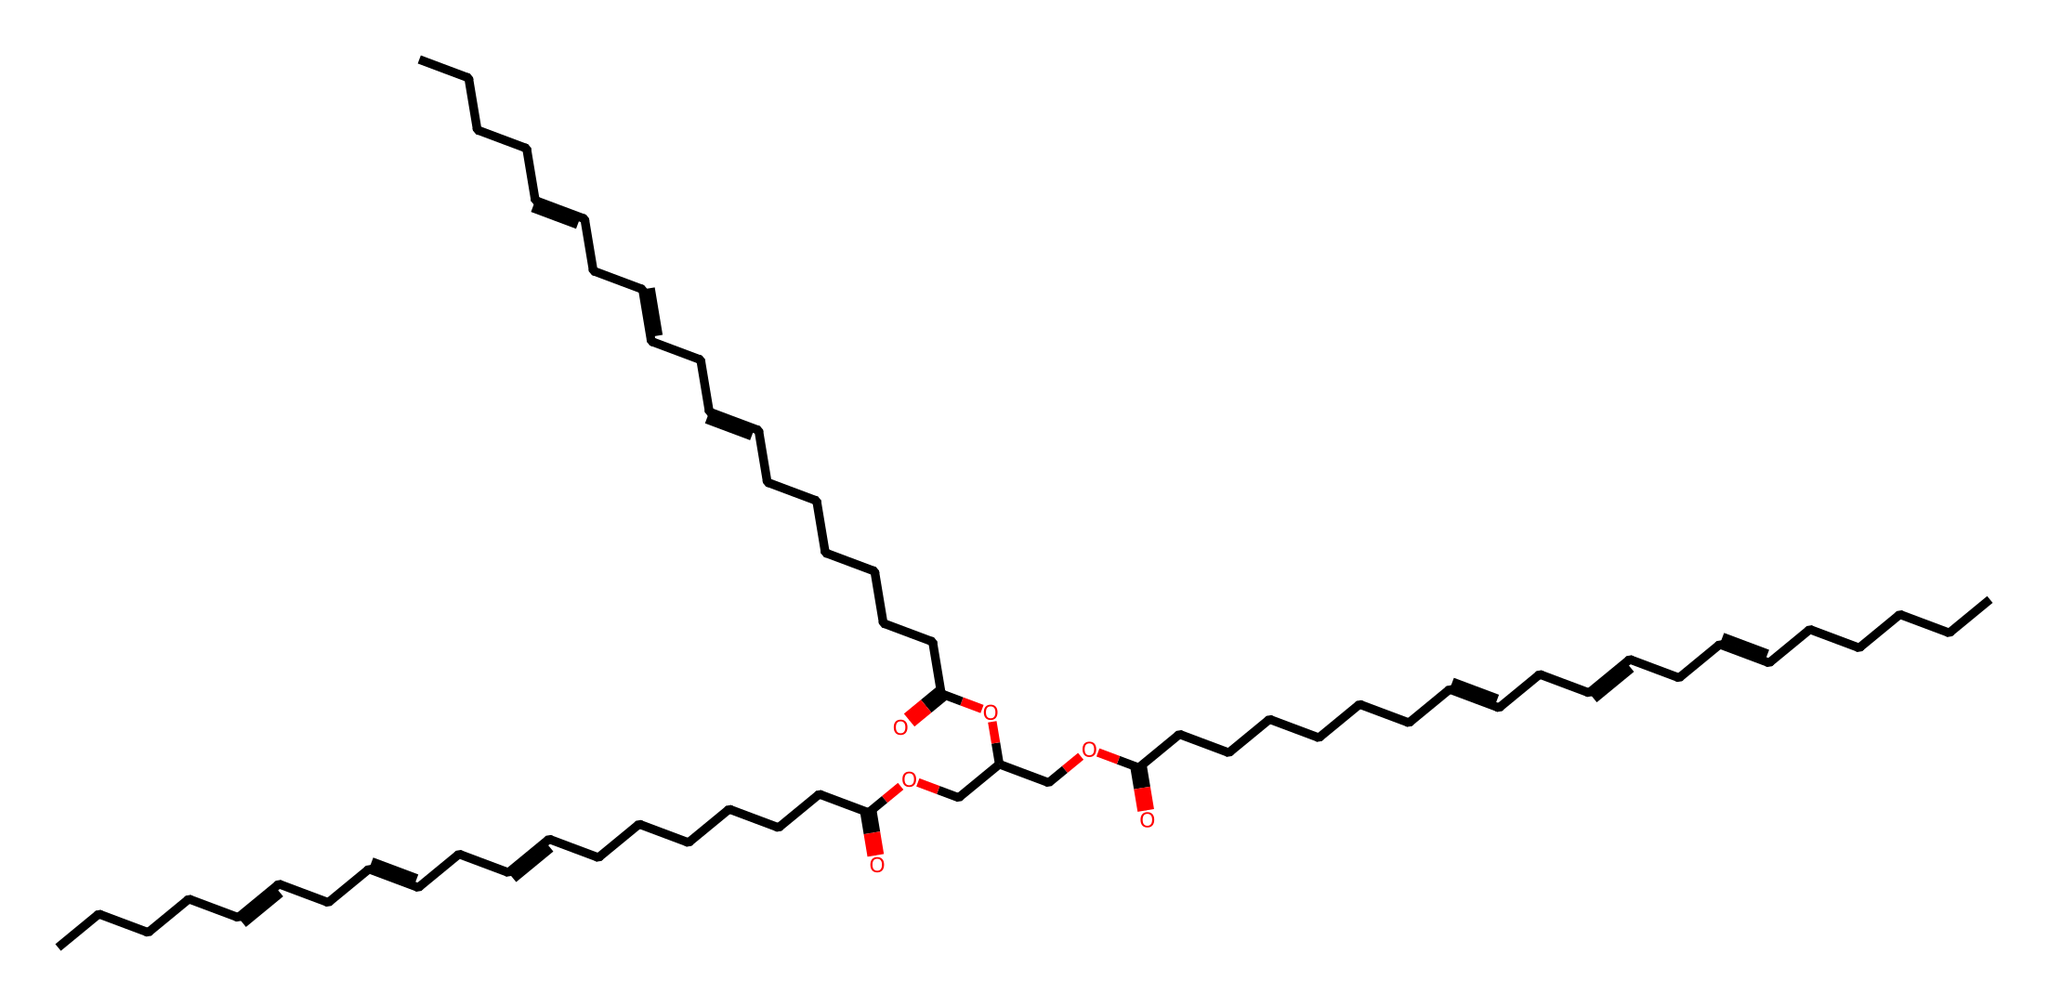how many carbon atoms are in linseed oil? To determine the number of carbon atoms, we can analyze the broken down structure from the SMILES representation. The longest carbon chain can be counted, considering the multiple branching points. After examining the molecule, we can conclude that there are 18 carbon atoms present.
Answer: 18 what type of functional group is present in linseed oil? In the SMILES representation, the presence of the "C(=O)" indicates a carboxylic acid functional group. This group is characterized by a carbon atom double-bonded to an oxygen atom and single-bonded to a hydroxyl group.
Answer: carboxylic acid how many double bonds are present in linseed oil? By examining the bonds represented in the SMILES notation, we look for "=" symbols which signify double bonds. After inspecting the structure, we find there are 3 double bonds present in the entire molecule.
Answer: 3 what is the purpose of linseed oil in preserving documents? Linseed oil has excellent properties such as being a natural lubricant and providing a protective layer. Its application in document preservation can be attributed to its ability to create a barrier against moisture and to enhance flexibility.
Answer: protective layer is linseed oil a saturated or unsaturated oil? By observing the presence of double bonds (-C=C-) in the structure, we can conclude that linseed oil contains unsaturation, which indicates that it is an unsaturated oil.
Answer: unsaturated what is the significance of the ester functional groups in linseed oil? The presence of ester functional groups (C=O followed by -O) serves as a crucial characteristic in linseed oil, as these groups impact its drying properties and stability when applied as a preservative.
Answer: drying properties 